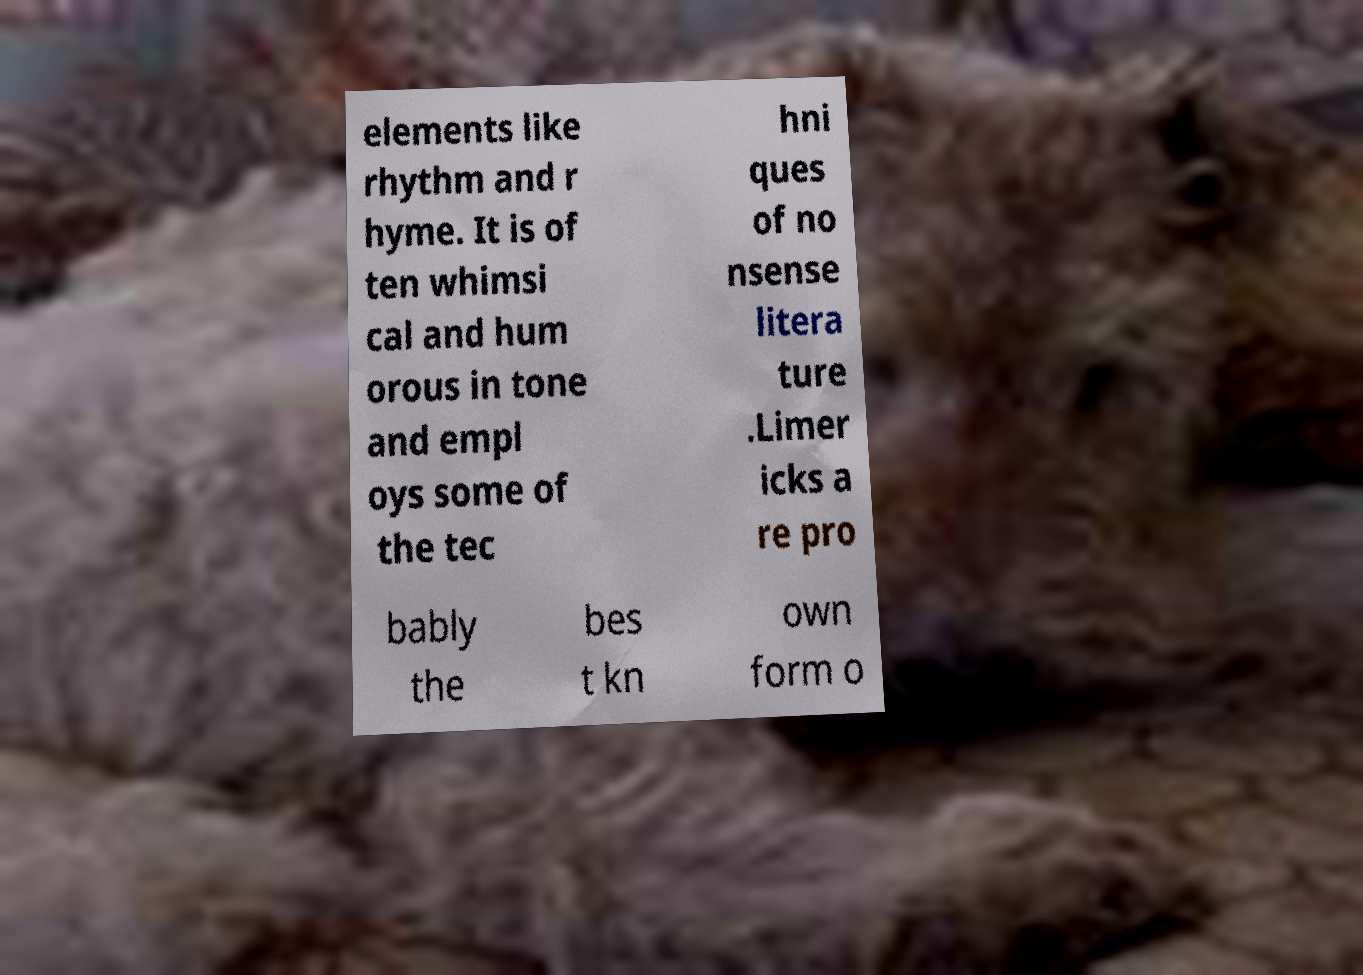Can you read and provide the text displayed in the image?This photo seems to have some interesting text. Can you extract and type it out for me? elements like rhythm and r hyme. It is of ten whimsi cal and hum orous in tone and empl oys some of the tec hni ques of no nsense litera ture .Limer icks a re pro bably the bes t kn own form o 